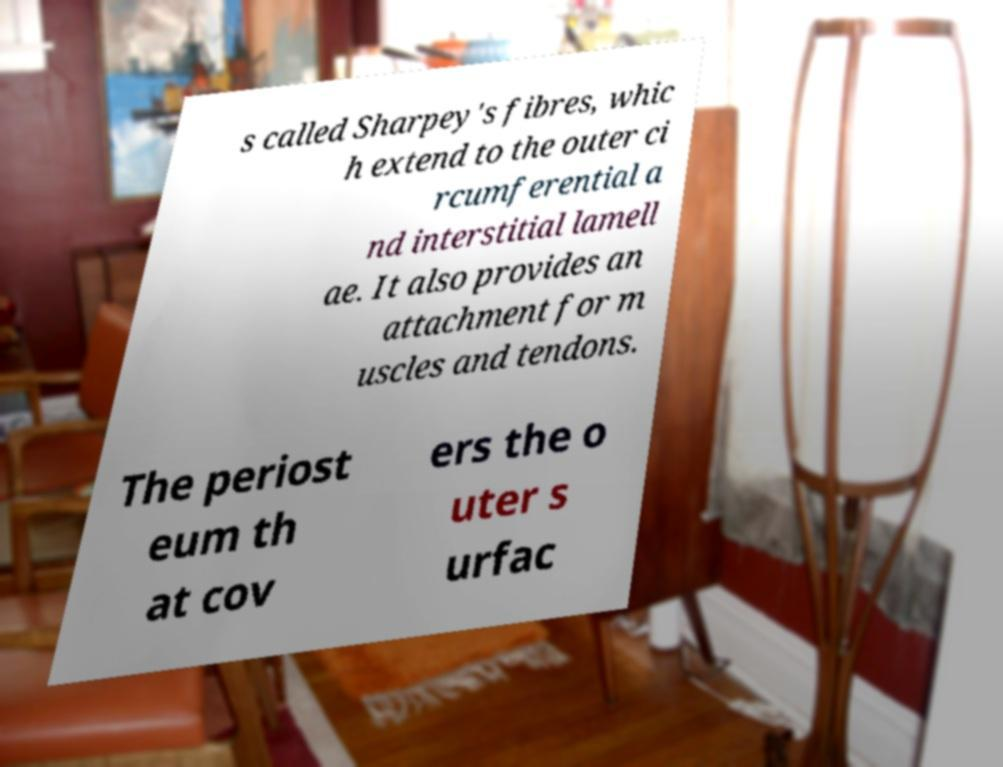Can you read and provide the text displayed in the image?This photo seems to have some interesting text. Can you extract and type it out for me? s called Sharpey's fibres, whic h extend to the outer ci rcumferential a nd interstitial lamell ae. It also provides an attachment for m uscles and tendons. The periost eum th at cov ers the o uter s urfac 